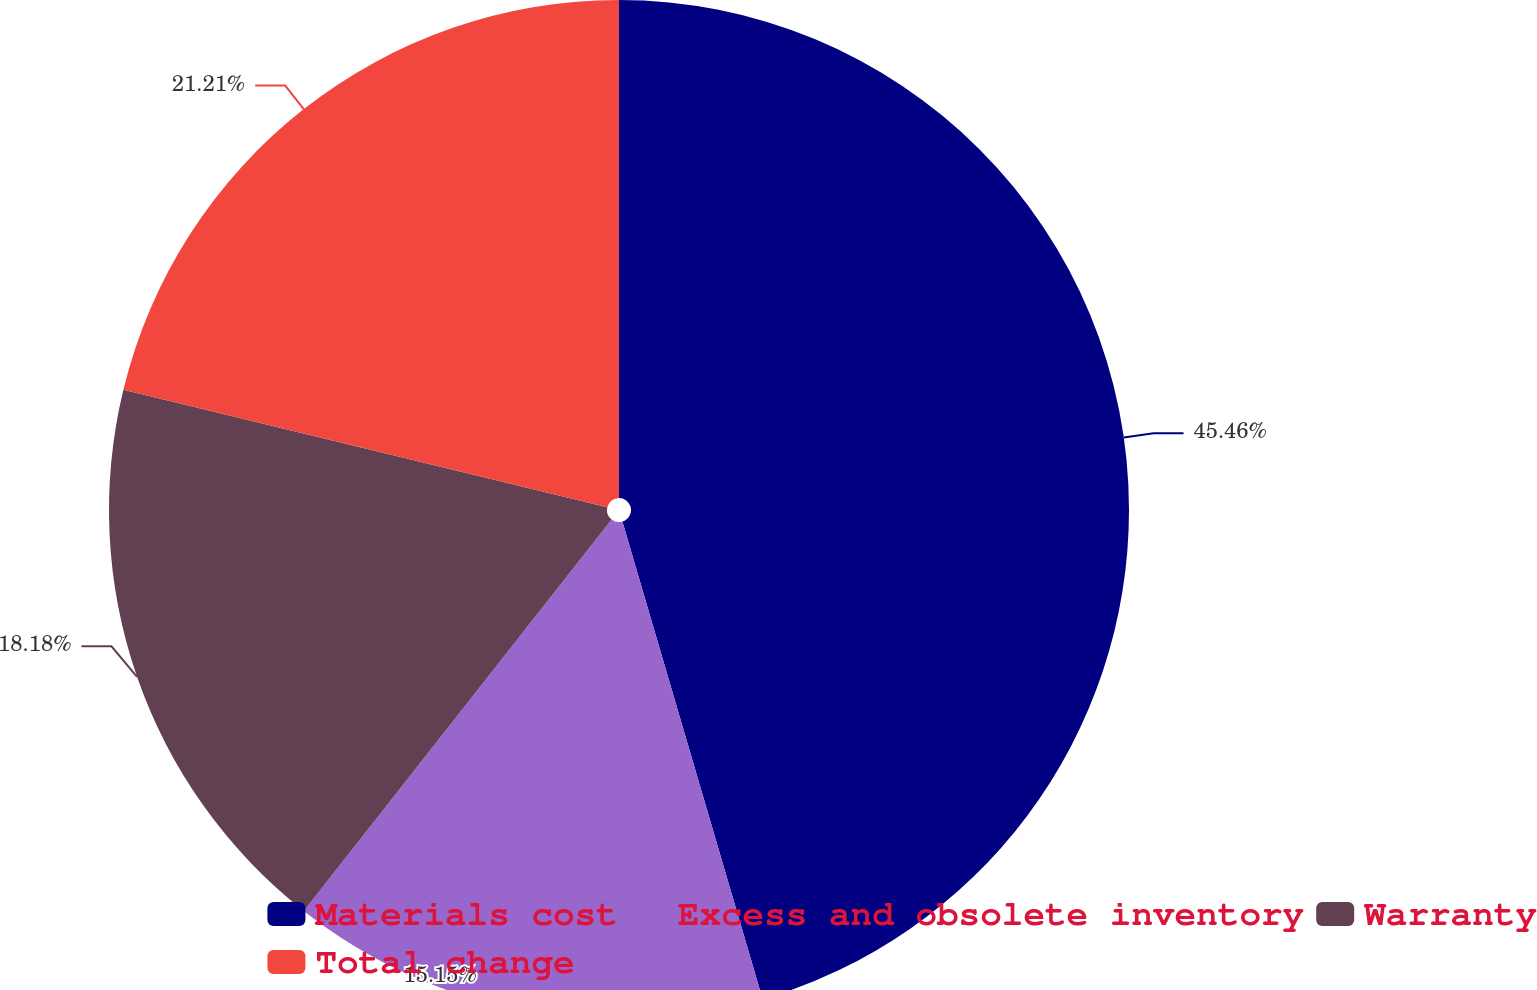<chart> <loc_0><loc_0><loc_500><loc_500><pie_chart><fcel>Materials cost<fcel>Excess and obsolete inventory<fcel>Warranty<fcel>Total change<nl><fcel>45.45%<fcel>15.15%<fcel>18.18%<fcel>21.21%<nl></chart> 